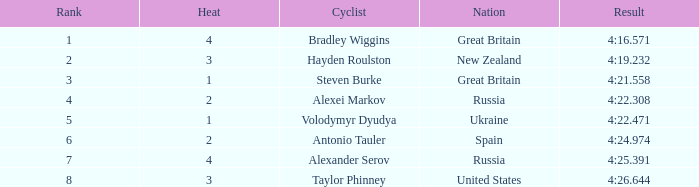What is the lowest rank that spain got? 6.0. 